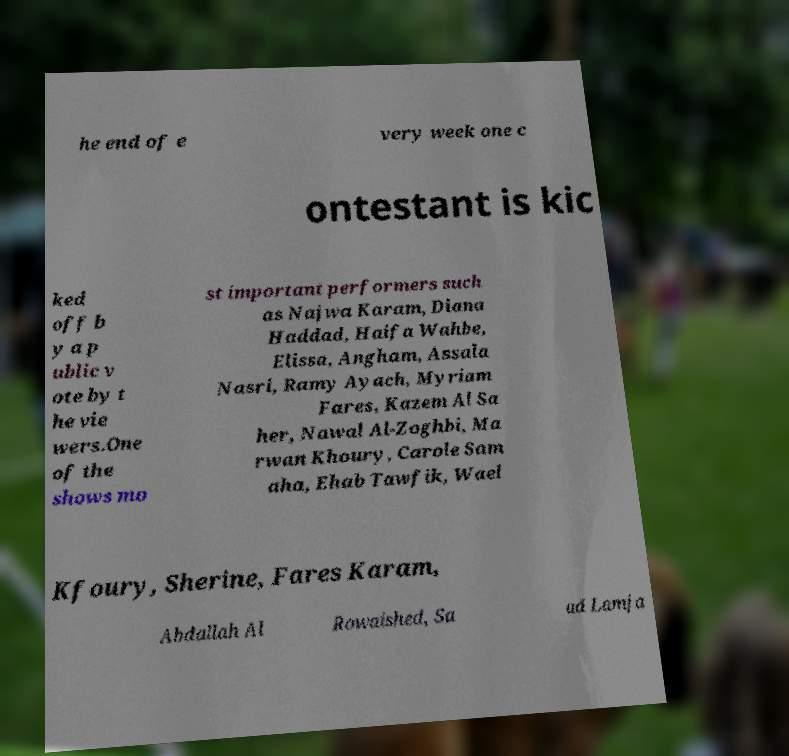Could you assist in decoding the text presented in this image and type it out clearly? he end of e very week one c ontestant is kic ked off b y a p ublic v ote by t he vie wers.One of the shows mo st important performers such as Najwa Karam, Diana Haddad, Haifa Wahbe, Elissa, Angham, Assala Nasri, Ramy Ayach, Myriam Fares, Kazem Al Sa her, Nawal Al-Zoghbi, Ma rwan Khoury, Carole Sam aha, Ehab Tawfik, Wael Kfoury, Sherine, Fares Karam, Abdallah Al Rowaished, Sa ad Lamja 